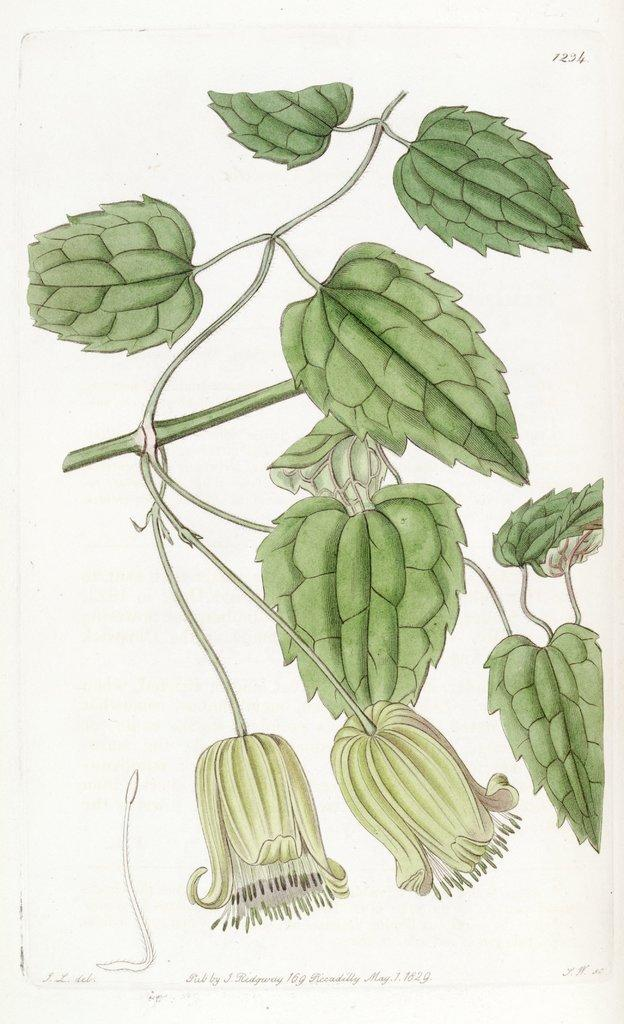What is the main subject of the image? There is a painting in the image. What is depicted in the painting? The painting depicts green leaves and flowers on a stem. What color is the robin in the image? There is no robin present in the image; the painting only depicts green leaves and flowers on a stem. How many chickens are visible in the image? There are no chickens present in the image; the painting only depicts green leaves and flowers on a stem. 